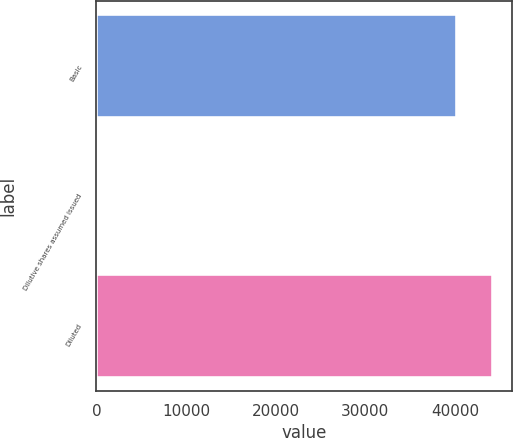Convert chart to OTSL. <chart><loc_0><loc_0><loc_500><loc_500><bar_chart><fcel>Basic<fcel>Dilutive shares assumed issued<fcel>Diluted<nl><fcel>40205<fcel>290<fcel>44225.5<nl></chart> 